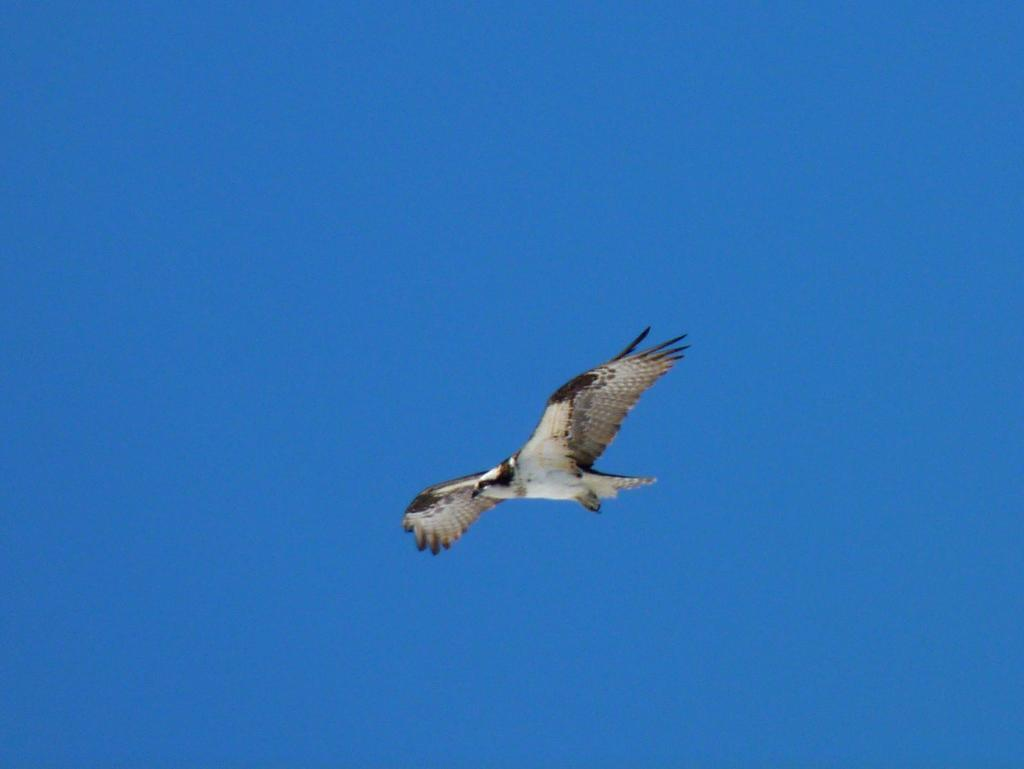What is the main subject of the image? The main subject of the image is a bird flying. What can be seen in the background of the image? The sky is visible in the background of the image. What type of zephyr is present in the image? There is no mention of a zephyr in the image, as it is a term related to wind and not visible in the image. 